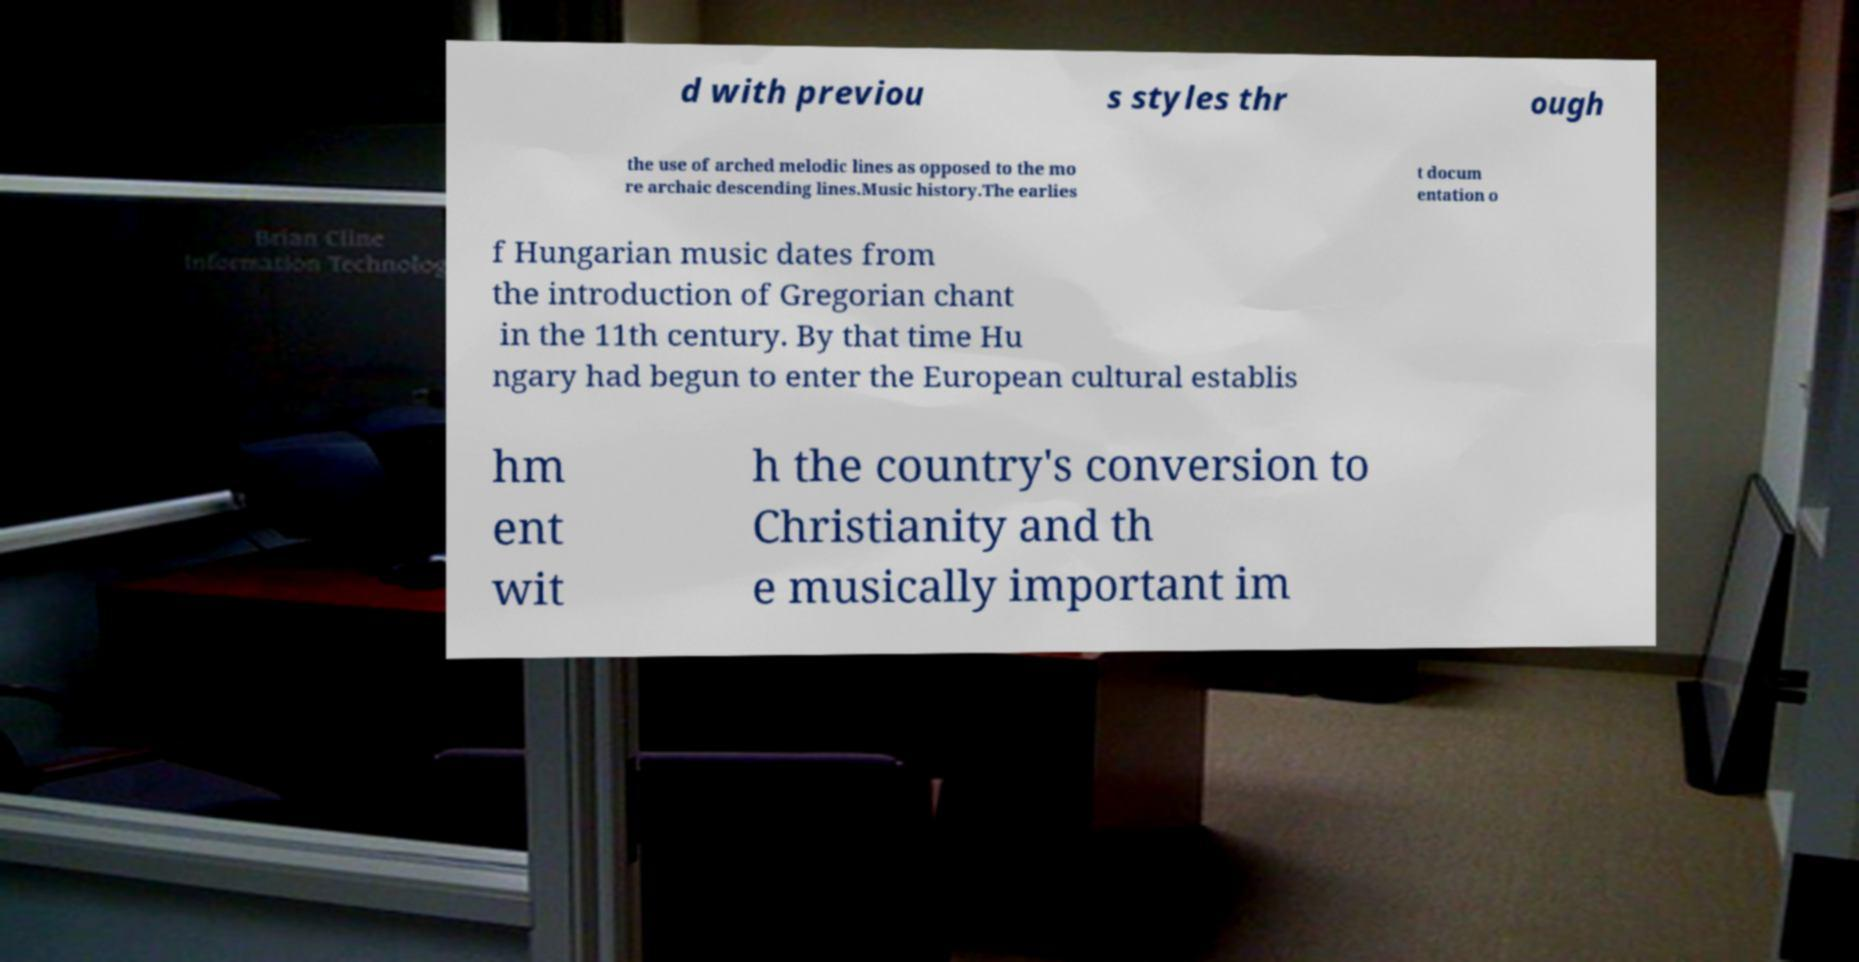What messages or text are displayed in this image? I need them in a readable, typed format. d with previou s styles thr ough the use of arched melodic lines as opposed to the mo re archaic descending lines.Music history.The earlies t docum entation o f Hungarian music dates from the introduction of Gregorian chant in the 11th century. By that time Hu ngary had begun to enter the European cultural establis hm ent wit h the country's conversion to Christianity and th e musically important im 